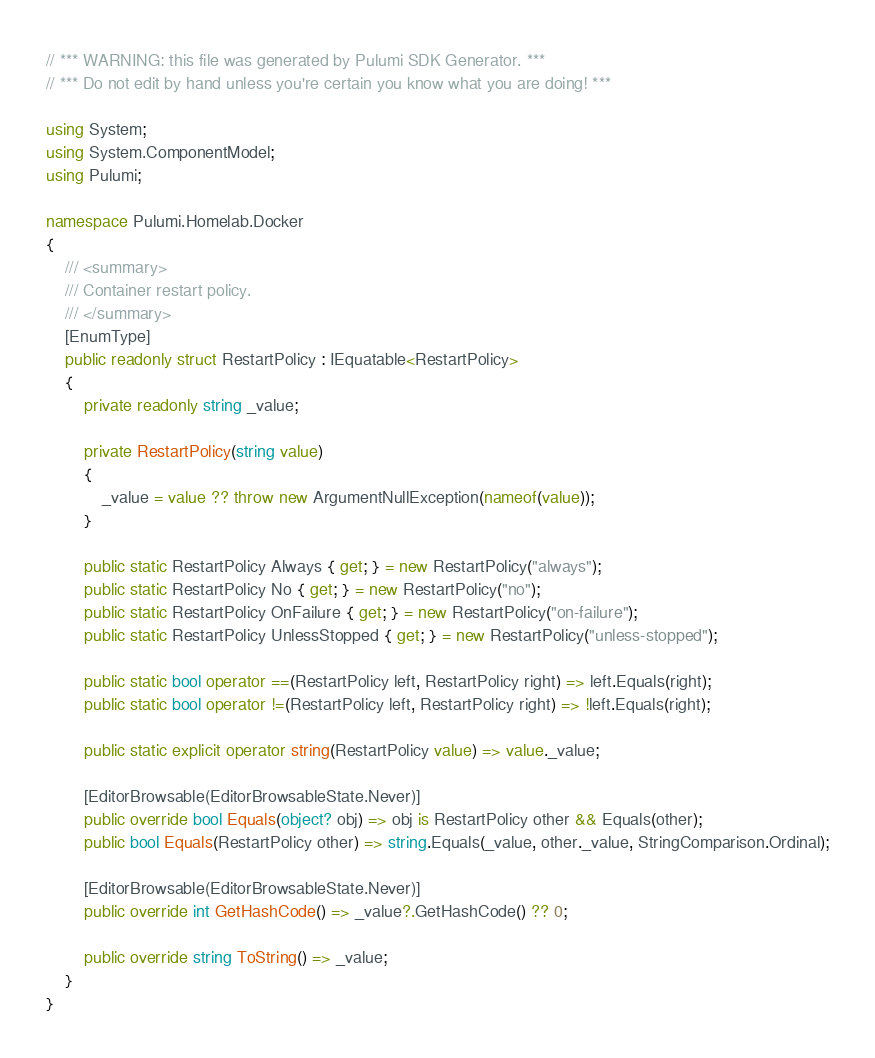Convert code to text. <code><loc_0><loc_0><loc_500><loc_500><_C#_>// *** WARNING: this file was generated by Pulumi SDK Generator. ***
// *** Do not edit by hand unless you're certain you know what you are doing! ***

using System;
using System.ComponentModel;
using Pulumi;

namespace Pulumi.Homelab.Docker
{
    /// <summary>
    /// Container restart policy.
    /// </summary>
    [EnumType]
    public readonly struct RestartPolicy : IEquatable<RestartPolicy>
    {
        private readonly string _value;

        private RestartPolicy(string value)
        {
            _value = value ?? throw new ArgumentNullException(nameof(value));
        }

        public static RestartPolicy Always { get; } = new RestartPolicy("always");
        public static RestartPolicy No { get; } = new RestartPolicy("no");
        public static RestartPolicy OnFailure { get; } = new RestartPolicy("on-failure");
        public static RestartPolicy UnlessStopped { get; } = new RestartPolicy("unless-stopped");

        public static bool operator ==(RestartPolicy left, RestartPolicy right) => left.Equals(right);
        public static bool operator !=(RestartPolicy left, RestartPolicy right) => !left.Equals(right);

        public static explicit operator string(RestartPolicy value) => value._value;

        [EditorBrowsable(EditorBrowsableState.Never)]
        public override bool Equals(object? obj) => obj is RestartPolicy other && Equals(other);
        public bool Equals(RestartPolicy other) => string.Equals(_value, other._value, StringComparison.Ordinal);

        [EditorBrowsable(EditorBrowsableState.Never)]
        public override int GetHashCode() => _value?.GetHashCode() ?? 0;

        public override string ToString() => _value;
    }
}
</code> 